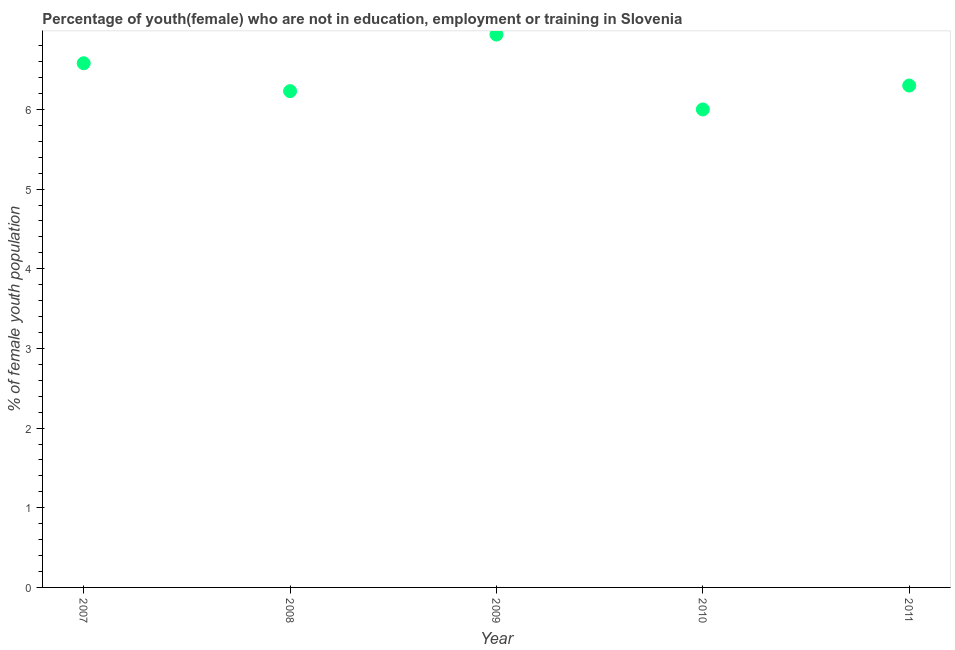What is the unemployed female youth population in 2008?
Give a very brief answer. 6.23. Across all years, what is the maximum unemployed female youth population?
Your response must be concise. 6.94. Across all years, what is the minimum unemployed female youth population?
Make the answer very short. 6. In which year was the unemployed female youth population maximum?
Keep it short and to the point. 2009. In which year was the unemployed female youth population minimum?
Your response must be concise. 2010. What is the sum of the unemployed female youth population?
Provide a short and direct response. 32.05. What is the difference between the unemployed female youth population in 2008 and 2011?
Offer a very short reply. -0.07. What is the average unemployed female youth population per year?
Ensure brevity in your answer.  6.41. What is the median unemployed female youth population?
Offer a very short reply. 6.3. In how many years, is the unemployed female youth population greater than 2.8 %?
Your response must be concise. 5. What is the ratio of the unemployed female youth population in 2008 to that in 2010?
Provide a short and direct response. 1.04. What is the difference between the highest and the second highest unemployed female youth population?
Keep it short and to the point. 0.36. Is the sum of the unemployed female youth population in 2009 and 2011 greater than the maximum unemployed female youth population across all years?
Your response must be concise. Yes. What is the difference between the highest and the lowest unemployed female youth population?
Ensure brevity in your answer.  0.94. Does the unemployed female youth population monotonically increase over the years?
Ensure brevity in your answer.  No. How many dotlines are there?
Keep it short and to the point. 1. How many years are there in the graph?
Your answer should be very brief. 5. What is the difference between two consecutive major ticks on the Y-axis?
Offer a terse response. 1. Does the graph contain any zero values?
Your response must be concise. No. What is the title of the graph?
Your response must be concise. Percentage of youth(female) who are not in education, employment or training in Slovenia. What is the label or title of the X-axis?
Offer a very short reply. Year. What is the label or title of the Y-axis?
Provide a short and direct response. % of female youth population. What is the % of female youth population in 2007?
Your response must be concise. 6.58. What is the % of female youth population in 2008?
Your response must be concise. 6.23. What is the % of female youth population in 2009?
Provide a short and direct response. 6.94. What is the % of female youth population in 2011?
Provide a succinct answer. 6.3. What is the difference between the % of female youth population in 2007 and 2008?
Offer a very short reply. 0.35. What is the difference between the % of female youth population in 2007 and 2009?
Make the answer very short. -0.36. What is the difference between the % of female youth population in 2007 and 2010?
Your response must be concise. 0.58. What is the difference between the % of female youth population in 2007 and 2011?
Your response must be concise. 0.28. What is the difference between the % of female youth population in 2008 and 2009?
Your response must be concise. -0.71. What is the difference between the % of female youth population in 2008 and 2010?
Make the answer very short. 0.23. What is the difference between the % of female youth population in 2008 and 2011?
Provide a short and direct response. -0.07. What is the difference between the % of female youth population in 2009 and 2010?
Offer a very short reply. 0.94. What is the difference between the % of female youth population in 2009 and 2011?
Your answer should be compact. 0.64. What is the ratio of the % of female youth population in 2007 to that in 2008?
Give a very brief answer. 1.06. What is the ratio of the % of female youth population in 2007 to that in 2009?
Provide a succinct answer. 0.95. What is the ratio of the % of female youth population in 2007 to that in 2010?
Offer a very short reply. 1.1. What is the ratio of the % of female youth population in 2007 to that in 2011?
Offer a terse response. 1.04. What is the ratio of the % of female youth population in 2008 to that in 2009?
Offer a very short reply. 0.9. What is the ratio of the % of female youth population in 2008 to that in 2010?
Your answer should be very brief. 1.04. What is the ratio of the % of female youth population in 2008 to that in 2011?
Make the answer very short. 0.99. What is the ratio of the % of female youth population in 2009 to that in 2010?
Your answer should be very brief. 1.16. What is the ratio of the % of female youth population in 2009 to that in 2011?
Give a very brief answer. 1.1. 